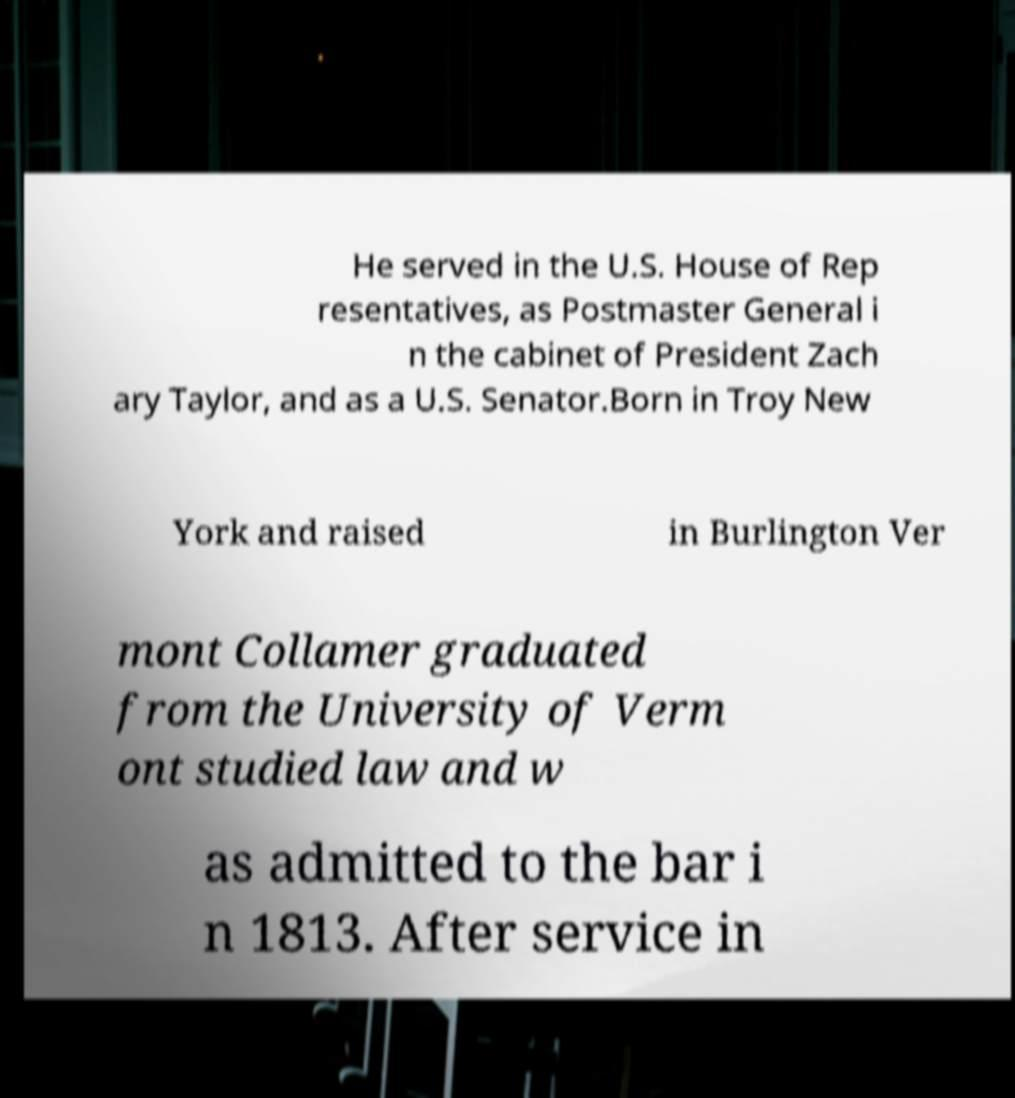There's text embedded in this image that I need extracted. Can you transcribe it verbatim? He served in the U.S. House of Rep resentatives, as Postmaster General i n the cabinet of President Zach ary Taylor, and as a U.S. Senator.Born in Troy New York and raised in Burlington Ver mont Collamer graduated from the University of Verm ont studied law and w as admitted to the bar i n 1813. After service in 